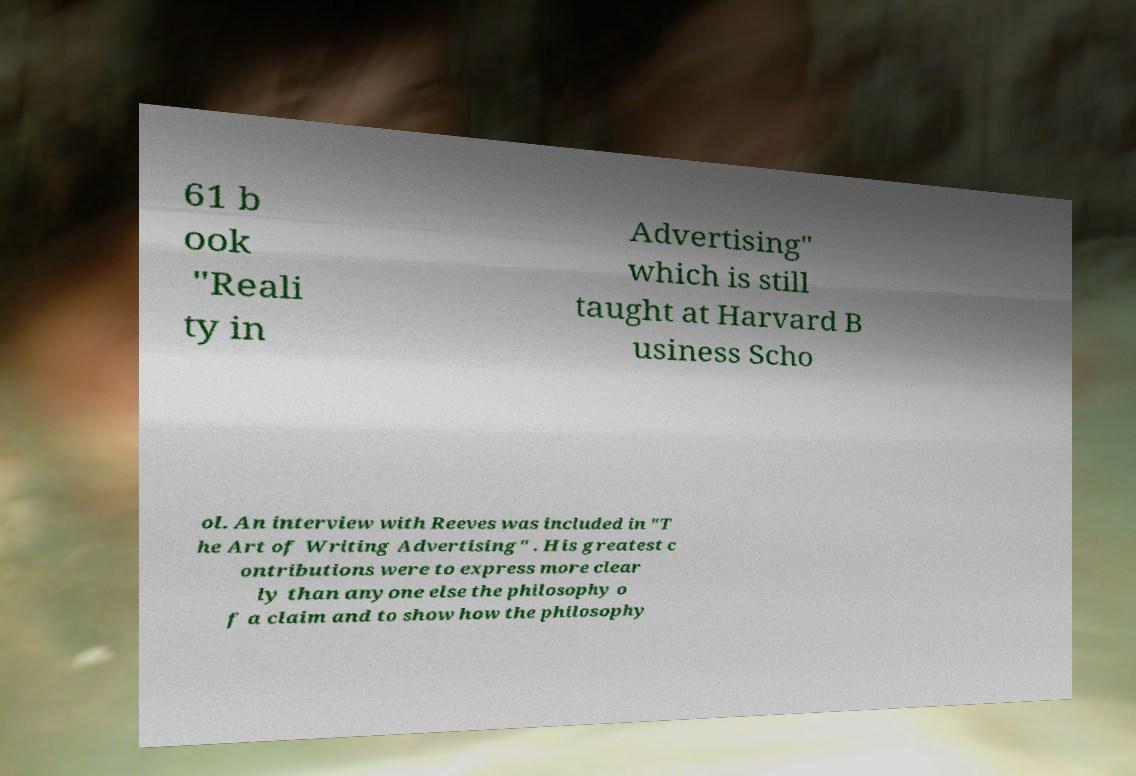Please identify and transcribe the text found in this image. 61 b ook "Reali ty in Advertising" which is still taught at Harvard B usiness Scho ol. An interview with Reeves was included in "T he Art of Writing Advertising" . His greatest c ontributions were to express more clear ly than anyone else the philosophy o f a claim and to show how the philosophy 